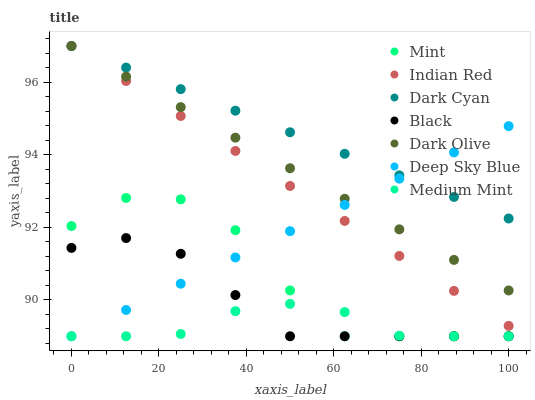Does Medium Mint have the minimum area under the curve?
Answer yes or no. Yes. Does Dark Cyan have the maximum area under the curve?
Answer yes or no. Yes. Does Indian Red have the minimum area under the curve?
Answer yes or no. No. Does Indian Red have the maximum area under the curve?
Answer yes or no. No. Is Indian Red the smoothest?
Answer yes or no. Yes. Is Mint the roughest?
Answer yes or no. Yes. Is Black the smoothest?
Answer yes or no. No. Is Black the roughest?
Answer yes or no. No. Does Medium Mint have the lowest value?
Answer yes or no. Yes. Does Indian Red have the lowest value?
Answer yes or no. No. Does Dark Cyan have the highest value?
Answer yes or no. Yes. Does Black have the highest value?
Answer yes or no. No. Is Mint less than Dark Cyan?
Answer yes or no. Yes. Is Indian Red greater than Mint?
Answer yes or no. Yes. Does Mint intersect Deep Sky Blue?
Answer yes or no. Yes. Is Mint less than Deep Sky Blue?
Answer yes or no. No. Is Mint greater than Deep Sky Blue?
Answer yes or no. No. Does Mint intersect Dark Cyan?
Answer yes or no. No. 